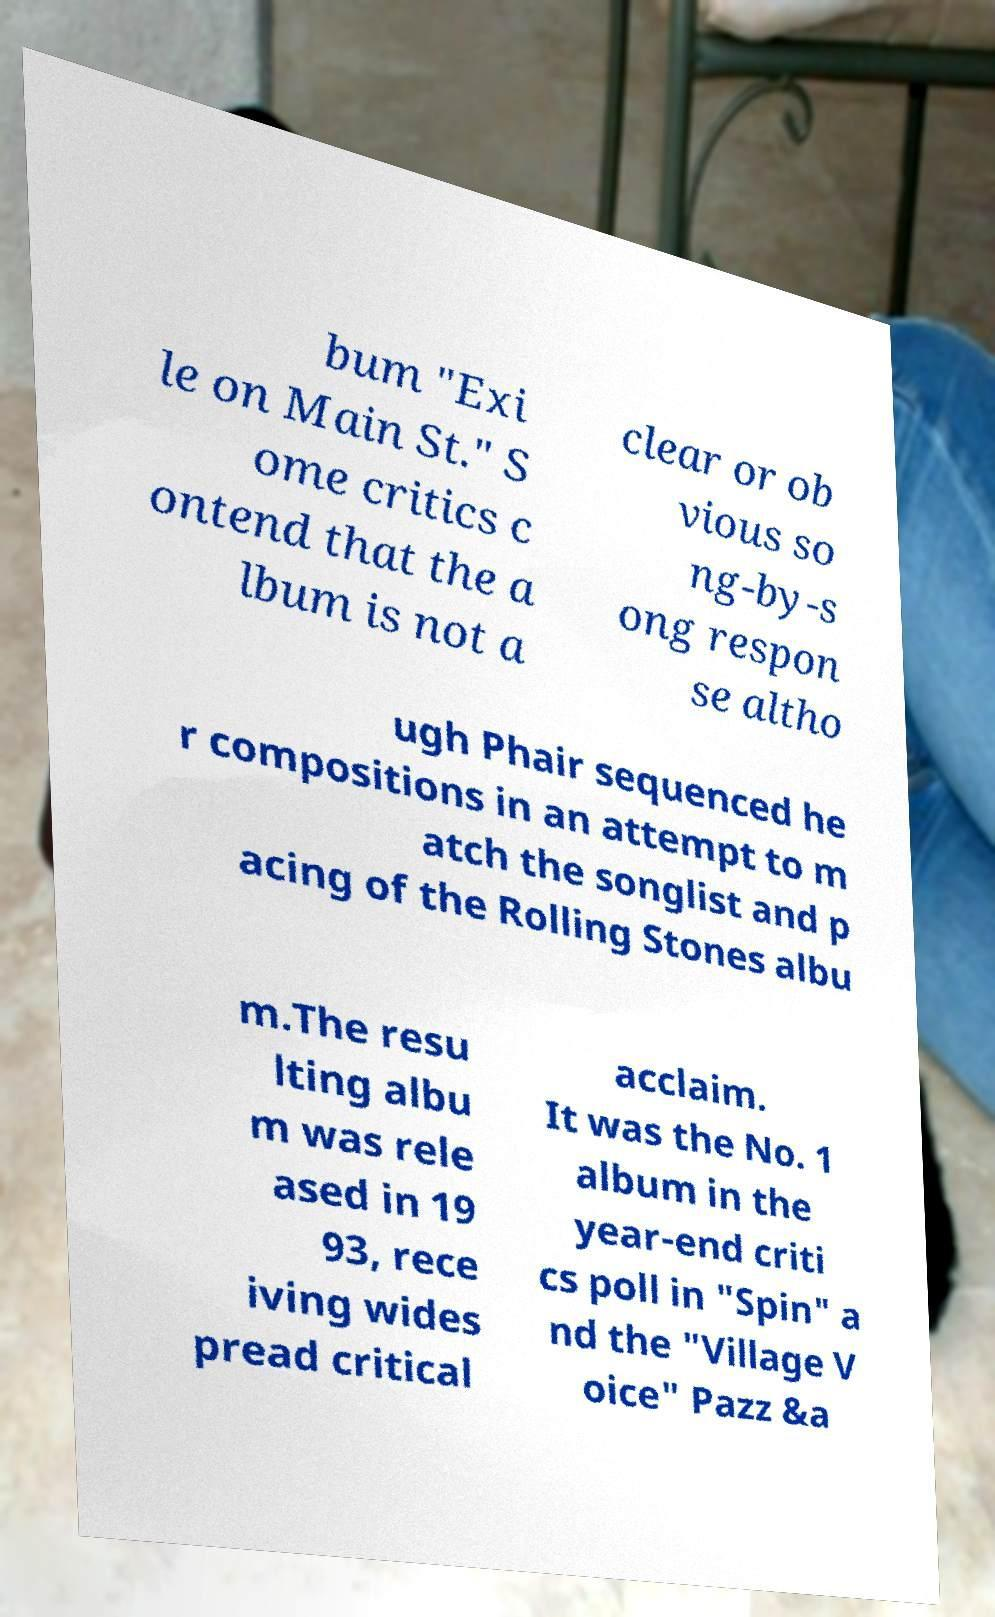Please read and relay the text visible in this image. What does it say? bum "Exi le on Main St." S ome critics c ontend that the a lbum is not a clear or ob vious so ng-by-s ong respon se altho ugh Phair sequenced he r compositions in an attempt to m atch the songlist and p acing of the Rolling Stones albu m.The resu lting albu m was rele ased in 19 93, rece iving wides pread critical acclaim. It was the No. 1 album in the year-end criti cs poll in "Spin" a nd the "Village V oice" Pazz &a 